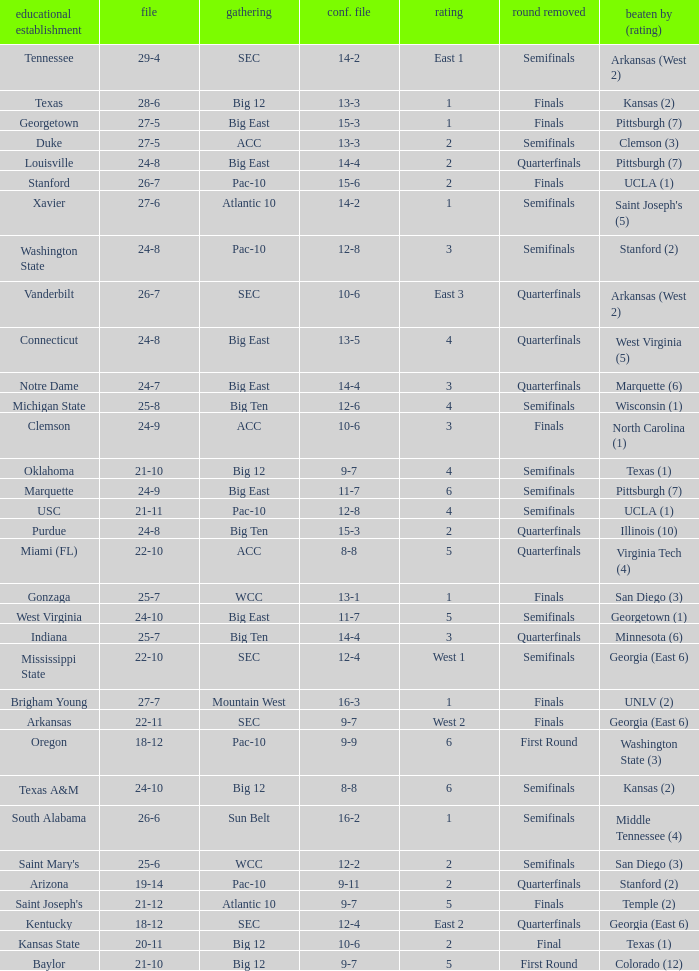Name the school where conference record is 12-6 Michigan State. 